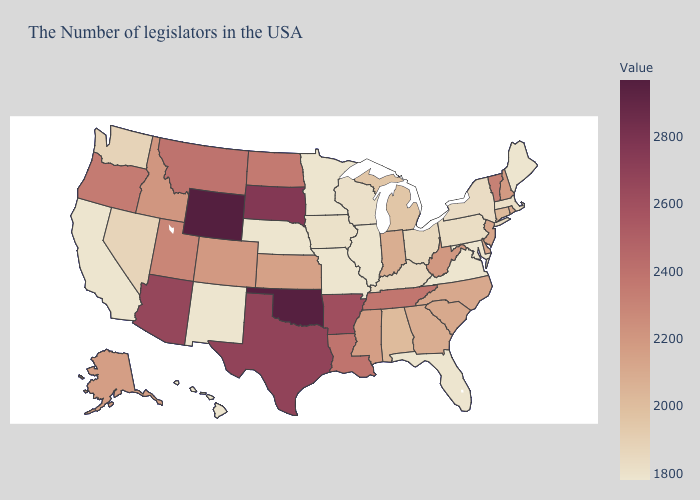Does Vermont have the highest value in the Northeast?
Answer briefly. Yes. Among the states that border Vermont , which have the lowest value?
Be succinct. Massachusetts. Does Wyoming have the highest value in the USA?
Keep it brief. Yes. Does the map have missing data?
Quick response, please. No. 